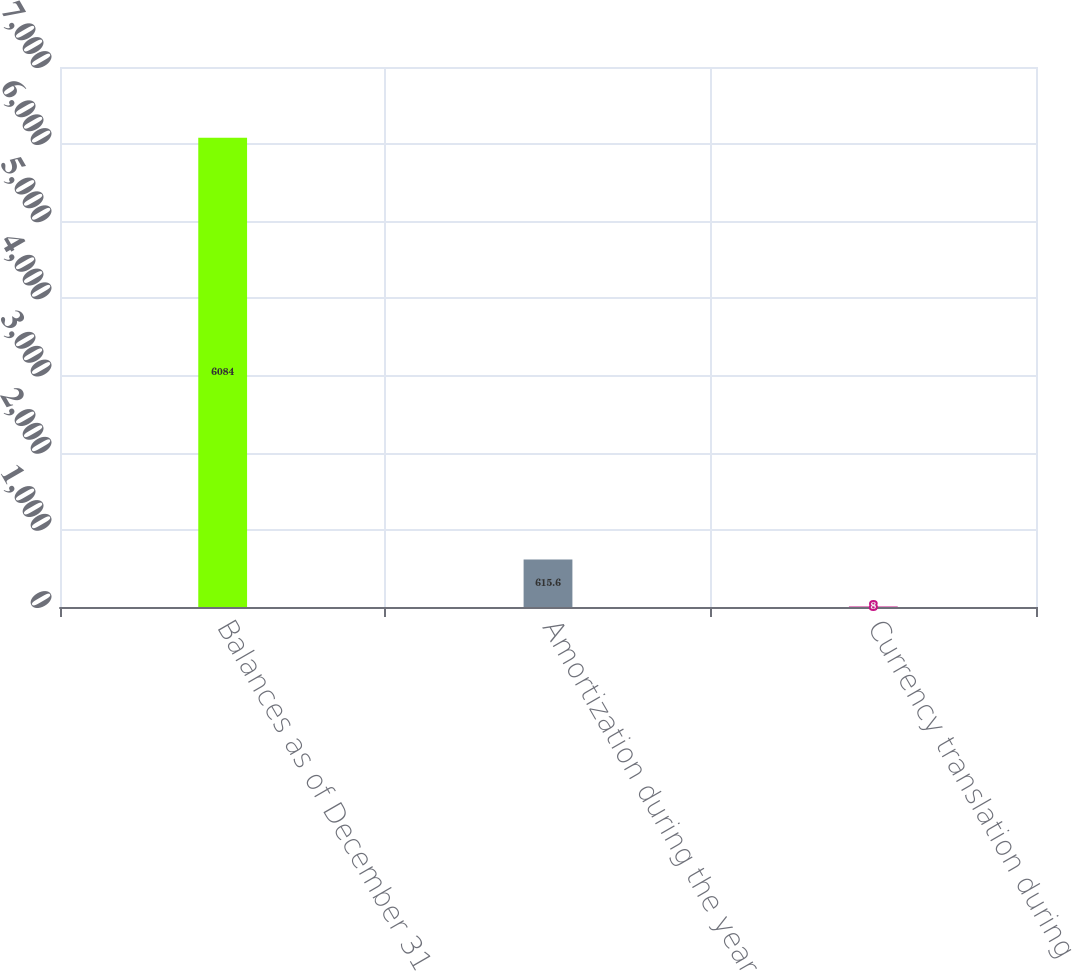<chart> <loc_0><loc_0><loc_500><loc_500><bar_chart><fcel>Balances as of December 31<fcel>Amortization during the year<fcel>Currency translation during<nl><fcel>6084<fcel>615.6<fcel>8<nl></chart> 